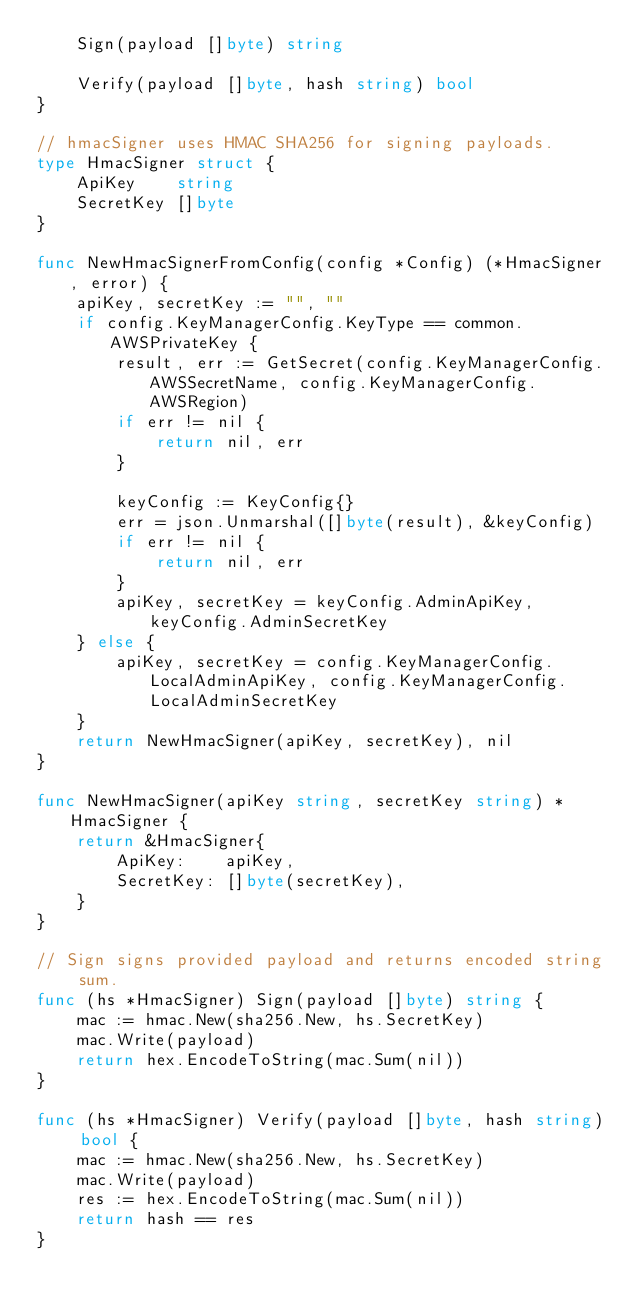Convert code to text. <code><loc_0><loc_0><loc_500><loc_500><_Go_>	Sign(payload []byte) string

	Verify(payload []byte, hash string) bool
}

// hmacSigner uses HMAC SHA256 for signing payloads.
type HmacSigner struct {
	ApiKey    string
	SecretKey []byte
}

func NewHmacSignerFromConfig(config *Config) (*HmacSigner, error) {
	apiKey, secretKey := "", ""
	if config.KeyManagerConfig.KeyType == common.AWSPrivateKey {
		result, err := GetSecret(config.KeyManagerConfig.AWSSecretName, config.KeyManagerConfig.AWSRegion)
		if err != nil {
			return nil, err
		}

		keyConfig := KeyConfig{}
		err = json.Unmarshal([]byte(result), &keyConfig)
		if err != nil {
			return nil, err
		}
		apiKey, secretKey = keyConfig.AdminApiKey, keyConfig.AdminSecretKey
	} else {
		apiKey, secretKey = config.KeyManagerConfig.LocalAdminApiKey, config.KeyManagerConfig.LocalAdminSecretKey
	}
	return NewHmacSigner(apiKey, secretKey), nil
}

func NewHmacSigner(apiKey string, secretKey string) *HmacSigner {
	return &HmacSigner{
		ApiKey:    apiKey,
		SecretKey: []byte(secretKey),
	}
}

// Sign signs provided payload and returns encoded string sum.
func (hs *HmacSigner) Sign(payload []byte) string {
	mac := hmac.New(sha256.New, hs.SecretKey)
	mac.Write(payload)
	return hex.EncodeToString(mac.Sum(nil))
}

func (hs *HmacSigner) Verify(payload []byte, hash string) bool {
	mac := hmac.New(sha256.New, hs.SecretKey)
	mac.Write(payload)
	res := hex.EncodeToString(mac.Sum(nil))
	return hash == res
}
</code> 